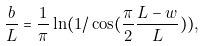<formula> <loc_0><loc_0><loc_500><loc_500>\frac { b } { L } = \frac { 1 } { \pi } \ln ( 1 / \cos ( \frac { \pi } { 2 } \frac { L - w } { L } ) ) ,</formula> 